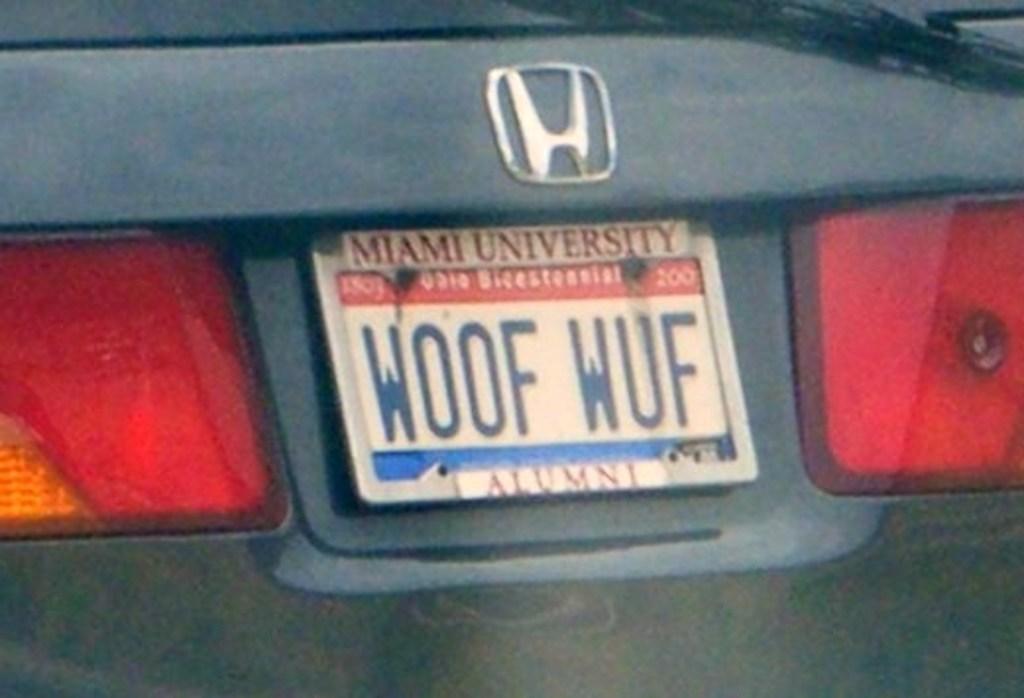Whats on the plate?
Make the answer very short. Woof wuf. 